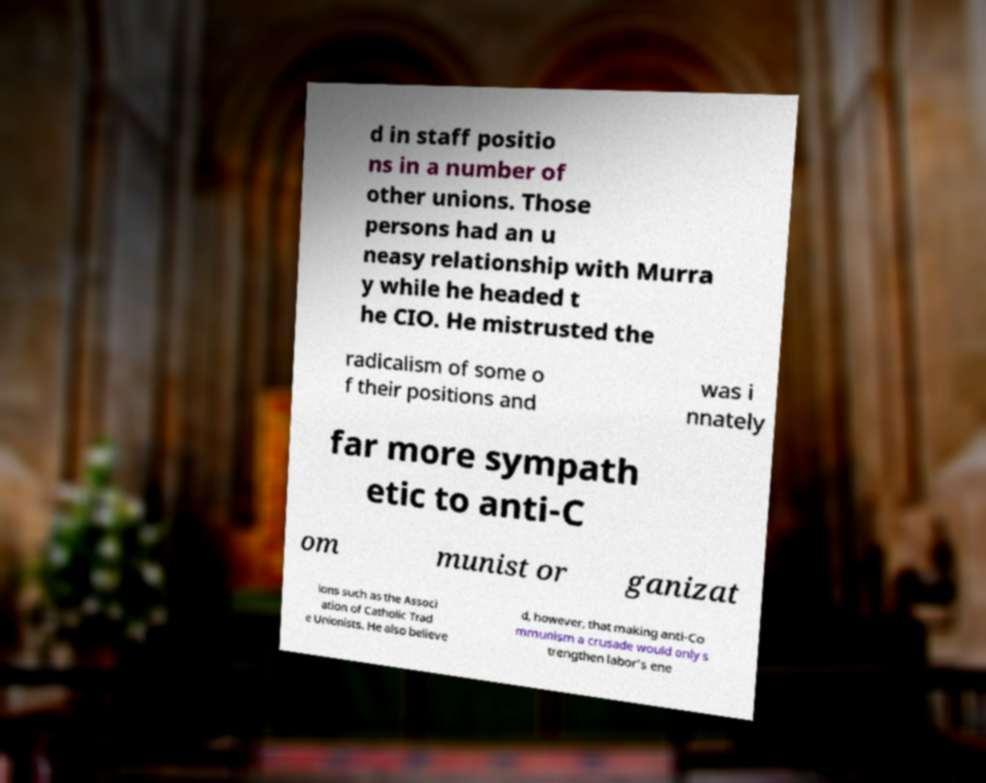Could you assist in decoding the text presented in this image and type it out clearly? d in staff positio ns in a number of other unions. Those persons had an u neasy relationship with Murra y while he headed t he CIO. He mistrusted the radicalism of some o f their positions and was i nnately far more sympath etic to anti-C om munist or ganizat ions such as the Associ ation of Catholic Trad e Unionists. He also believe d, however, that making anti-Co mmunism a crusade would only s trengthen labor's ene 